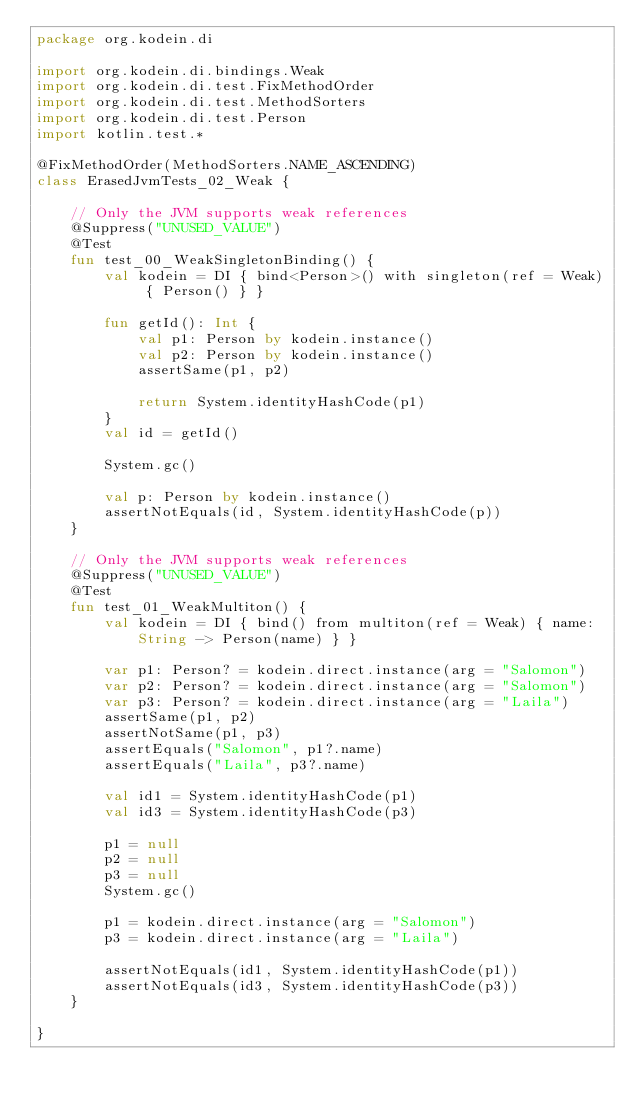<code> <loc_0><loc_0><loc_500><loc_500><_Kotlin_>package org.kodein.di

import org.kodein.di.bindings.Weak
import org.kodein.di.test.FixMethodOrder
import org.kodein.di.test.MethodSorters
import org.kodein.di.test.Person
import kotlin.test.*

@FixMethodOrder(MethodSorters.NAME_ASCENDING)
class ErasedJvmTests_02_Weak {

    // Only the JVM supports weak references
    @Suppress("UNUSED_VALUE")
    @Test
    fun test_00_WeakSingletonBinding() {
        val kodein = DI { bind<Person>() with singleton(ref = Weak) { Person() } }

        fun getId(): Int {
            val p1: Person by kodein.instance()
            val p2: Person by kodein.instance()
            assertSame(p1, p2)

            return System.identityHashCode(p1)
        }
        val id = getId()

        System.gc()

        val p: Person by kodein.instance()
        assertNotEquals(id, System.identityHashCode(p))
    }

    // Only the JVM supports weak references
    @Suppress("UNUSED_VALUE")
    @Test
    fun test_01_WeakMultiton() {
        val kodein = DI { bind() from multiton(ref = Weak) { name: String -> Person(name) } }

        var p1: Person? = kodein.direct.instance(arg = "Salomon")
        var p2: Person? = kodein.direct.instance(arg = "Salomon")
        var p3: Person? = kodein.direct.instance(arg = "Laila")
        assertSame(p1, p2)
        assertNotSame(p1, p3)
        assertEquals("Salomon", p1?.name)
        assertEquals("Laila", p3?.name)

        val id1 = System.identityHashCode(p1)
        val id3 = System.identityHashCode(p3)

        p1 = null
        p2 = null
        p3 = null
        System.gc()

        p1 = kodein.direct.instance(arg = "Salomon")
        p3 = kodein.direct.instance(arg = "Laila")

        assertNotEquals(id1, System.identityHashCode(p1))
        assertNotEquals(id3, System.identityHashCode(p3))
    }

}
</code> 